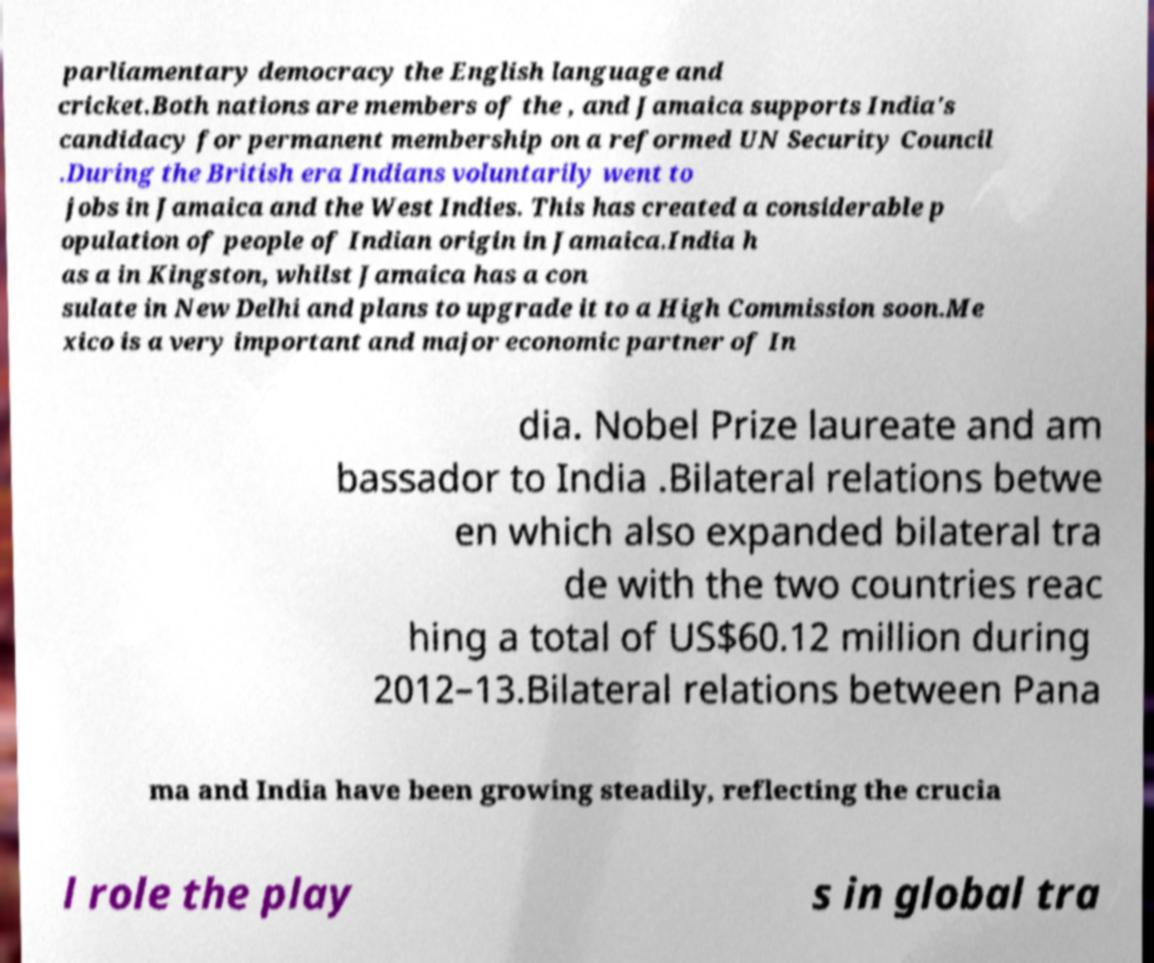Please read and relay the text visible in this image. What does it say? parliamentary democracy the English language and cricket.Both nations are members of the , and Jamaica supports India's candidacy for permanent membership on a reformed UN Security Council .During the British era Indians voluntarily went to jobs in Jamaica and the West Indies. This has created a considerable p opulation of people of Indian origin in Jamaica.India h as a in Kingston, whilst Jamaica has a con sulate in New Delhi and plans to upgrade it to a High Commission soon.Me xico is a very important and major economic partner of In dia. Nobel Prize laureate and am bassador to India .Bilateral relations betwe en which also expanded bilateral tra de with the two countries reac hing a total of US$60.12 million during 2012–13.Bilateral relations between Pana ma and India have been growing steadily, reflecting the crucia l role the play s in global tra 